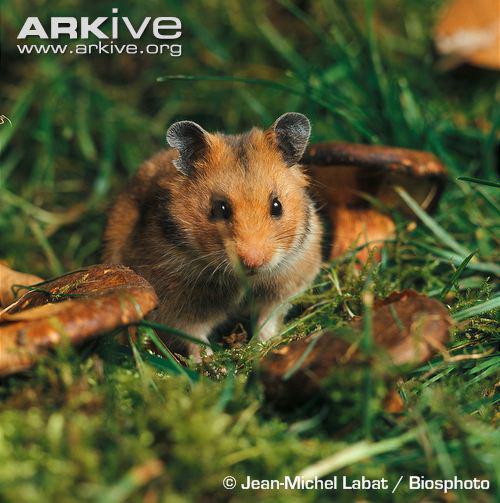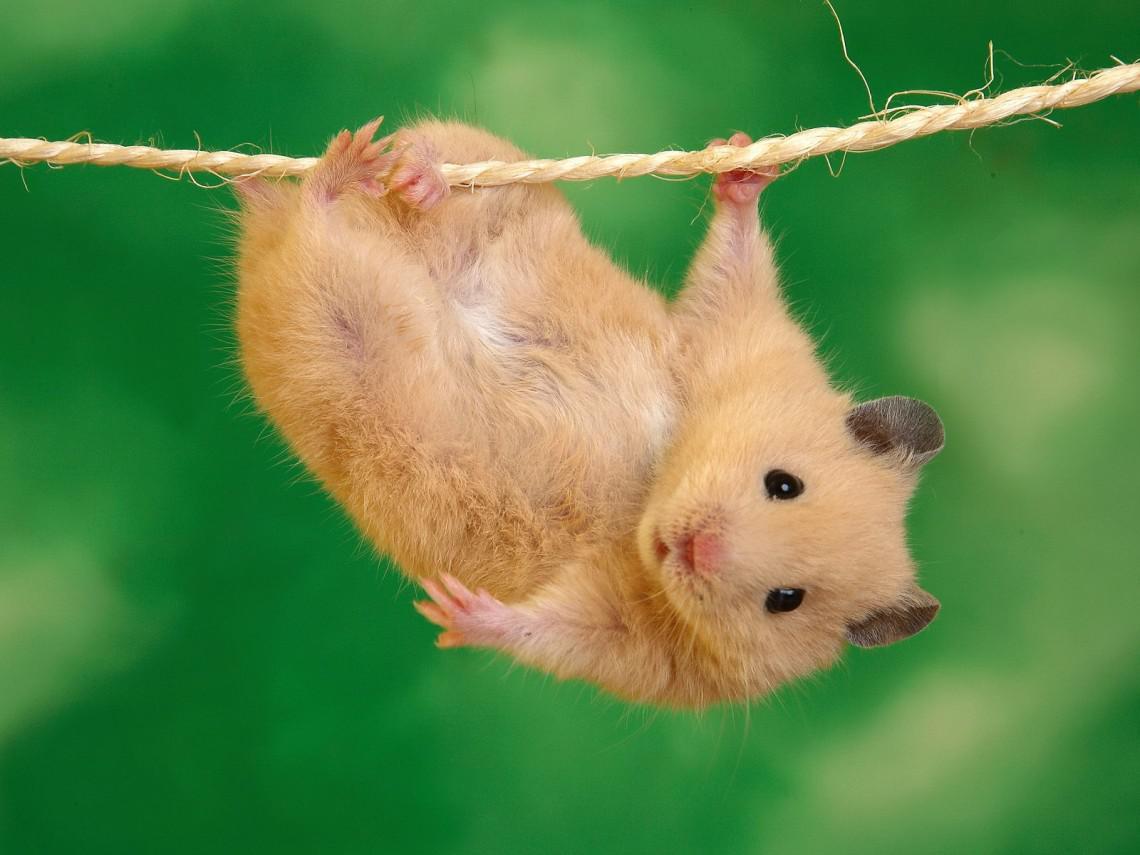The first image is the image on the left, the second image is the image on the right. Assess this claim about the two images: "At least one of the rodents is outside.". Correct or not? Answer yes or no. Yes. 